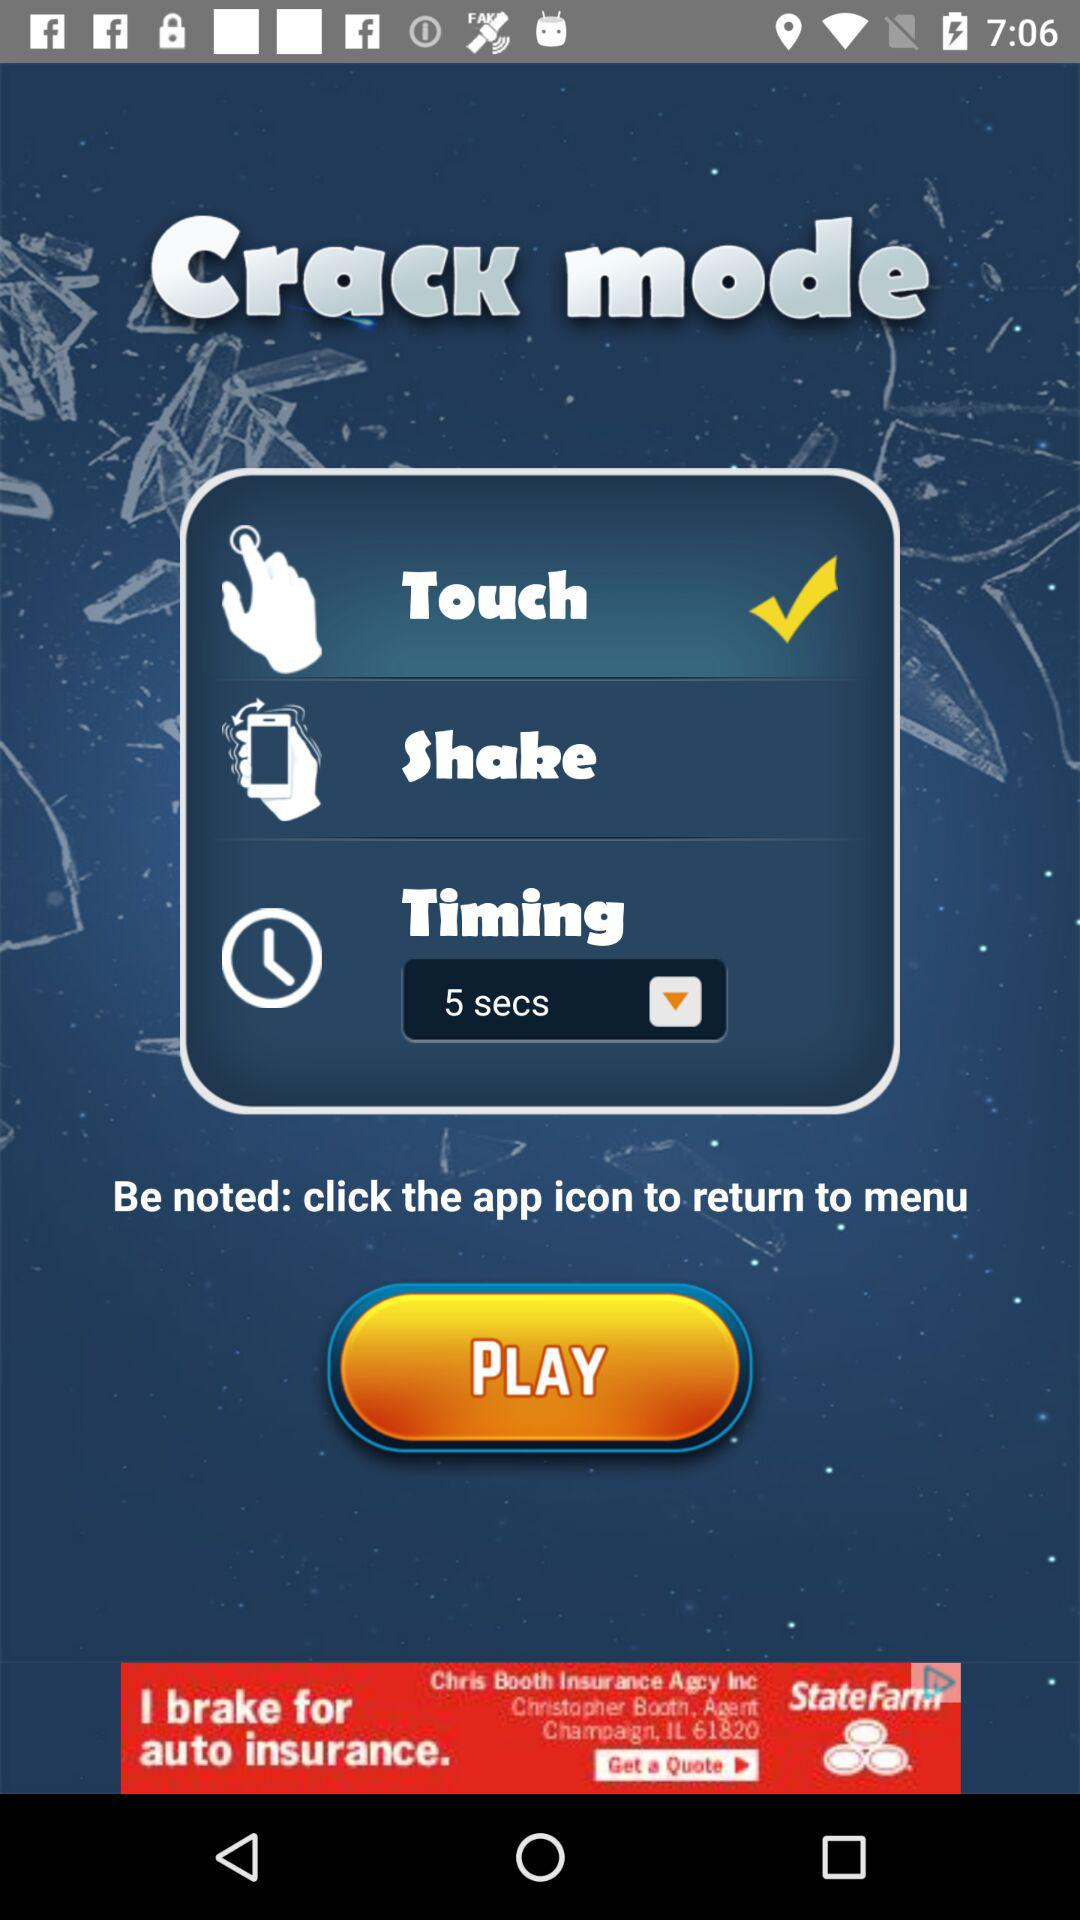What's the selected option? The selected option is "Touch". 